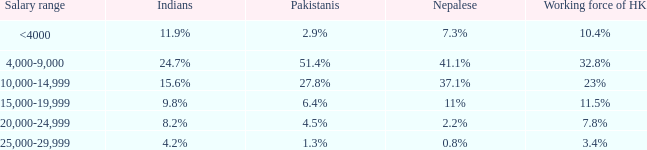If the nepalese population is 3 23%. 